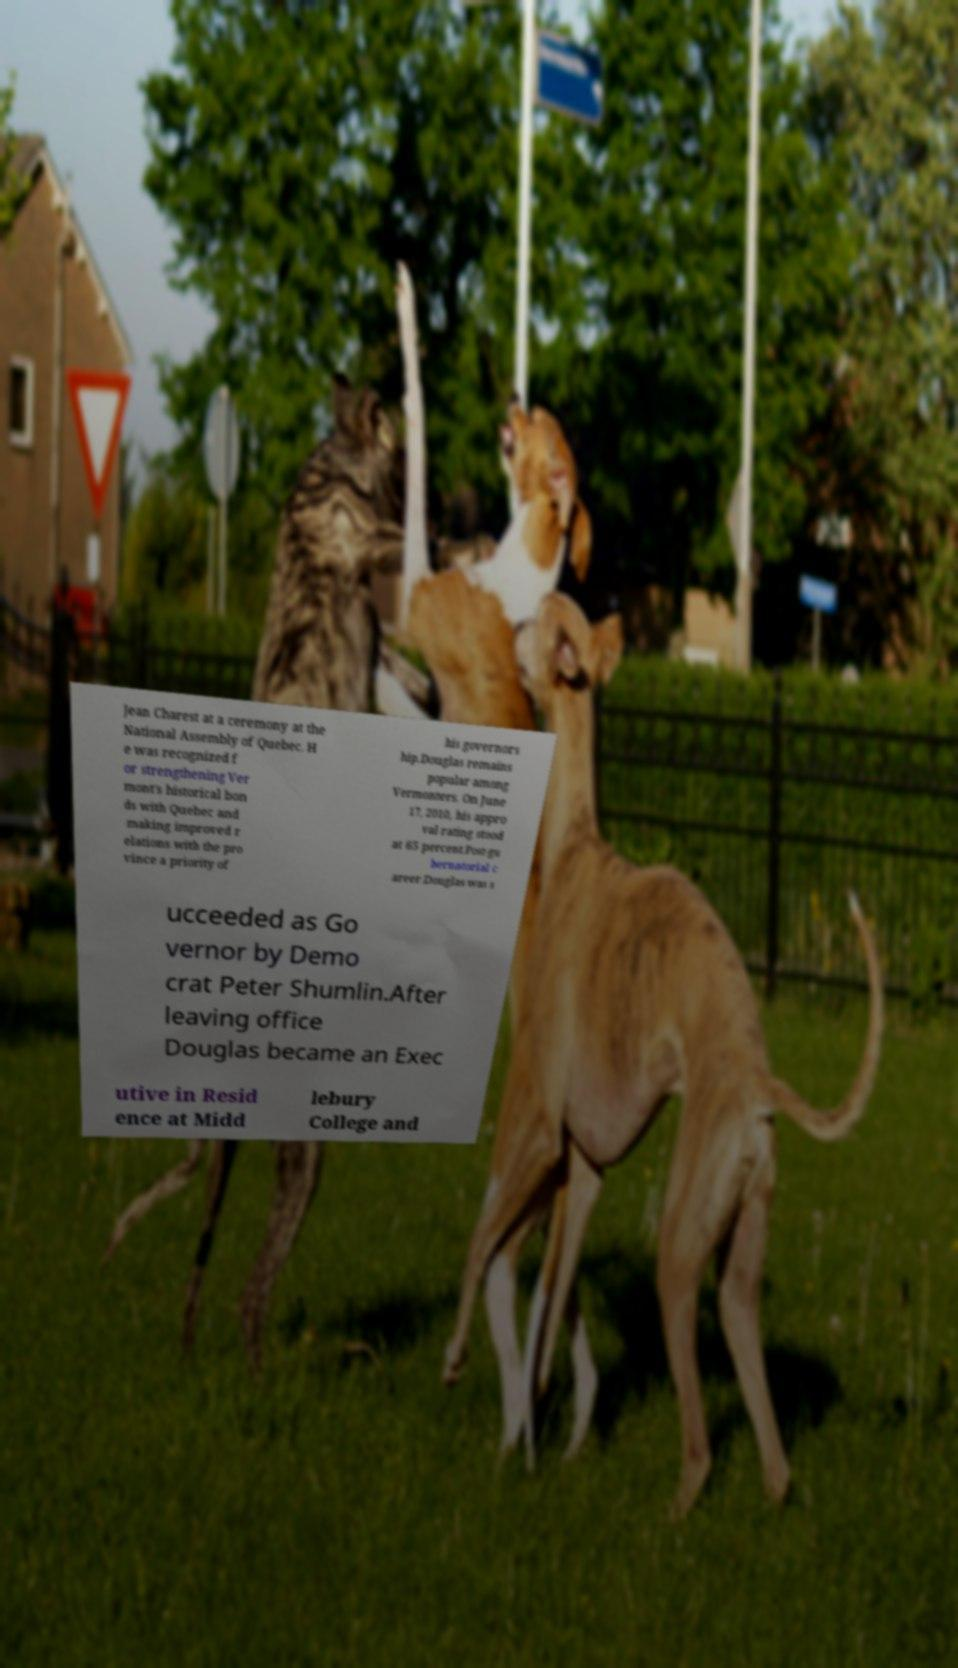Please read and relay the text visible in this image. What does it say? Jean Charest at a ceremony at the National Assembly of Quebec. H e was recognized f or strengthening Ver mont's historical bon ds with Quebec and making improved r elations with the pro vince a priority of his governors hip.Douglas remains popular among Vermonters. On June 17, 2010, his appro val rating stood at 65 percent.Post-gu bernatorial c areer.Douglas was s ucceeded as Go vernor by Demo crat Peter Shumlin.After leaving office Douglas became an Exec utive in Resid ence at Midd lebury College and 